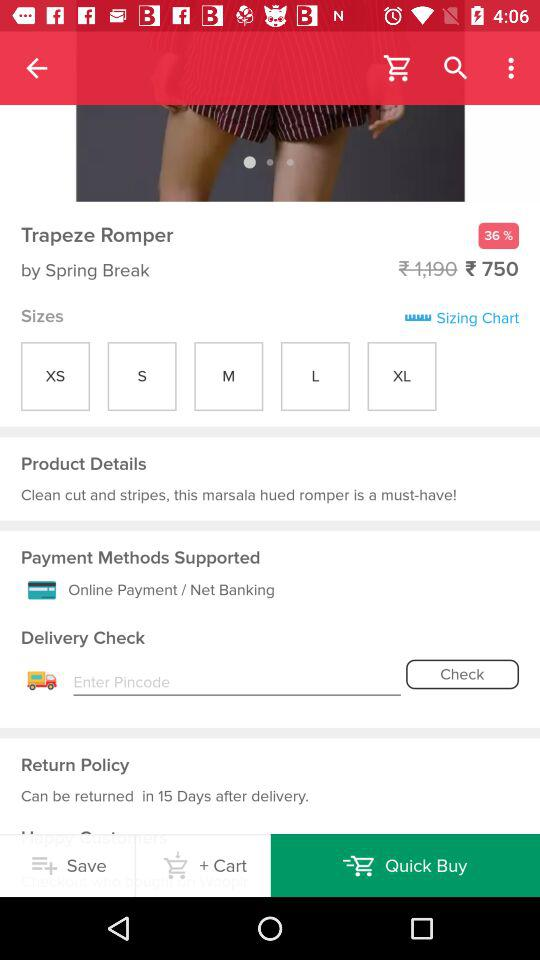Which size option is selected?
When the provided information is insufficient, respond with <no answer>. <no answer> 